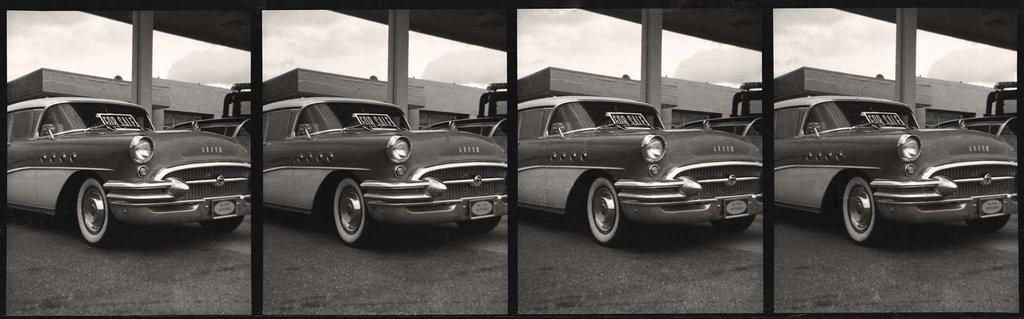What is the main subject in the image? There is a vehicle in the image. What else can be seen in the image besides the vehicle? There is a building and the sky visible in the image. How is the image composed? The image is a collage picture. Can you tell me how many cherries are on the vehicle in the image? There are no cherries present on the vehicle in the image. Is there a nest visible in the image? There is no nest visible in the image. 